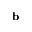<formula> <loc_0><loc_0><loc_500><loc_500>b</formula> 